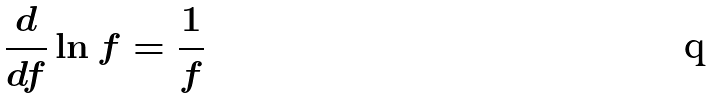<formula> <loc_0><loc_0><loc_500><loc_500>\frac { d } { d f } \ln f = \frac { 1 } { f }</formula> 